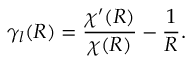Convert formula to latex. <formula><loc_0><loc_0><loc_500><loc_500>\gamma _ { l } ( R ) = \frac { \chi ^ { \prime } ( R ) } { \chi ( R ) } - \frac { 1 } { R } .</formula> 